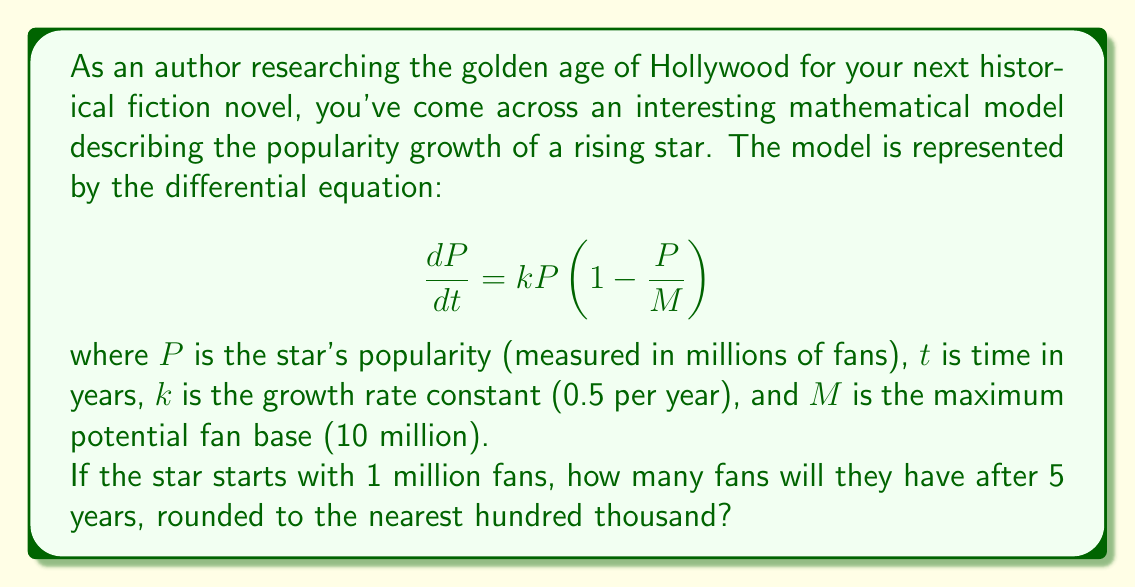Show me your answer to this math problem. To solve this problem, we need to follow these steps:

1) The given differential equation is a logistic growth model. Its solution is:

   $$P(t) = \frac{M}{1 + (\frac{M}{P_0} - 1)e^{-kt}}$$

   where $P_0$ is the initial popularity.

2) We're given:
   $M = 10$ million
   $k = 0.5$ per year
   $P_0 = 1$ million
   $t = 5$ years

3) Let's substitute these values into the equation:

   $$P(5) = \frac{10}{1 + (\frac{10}{1} - 1)e^{-0.5(5)}}$$

4) Simplify:
   $$P(5) = \frac{10}{1 + 9e^{-2.5}}$$

5) Calculate $e^{-2.5} \approx 0.0821$:
   $$P(5) = \frac{10}{1 + 9(0.0821)} \approx \frac{10}{1.7389}$$

6) Divide:
   $$P(5) \approx 5.7507$$ million fans

7) Rounding to the nearest hundred thousand:
   $$P(5) \approx 5.8$$ million fans
Answer: 5.8 million fans 